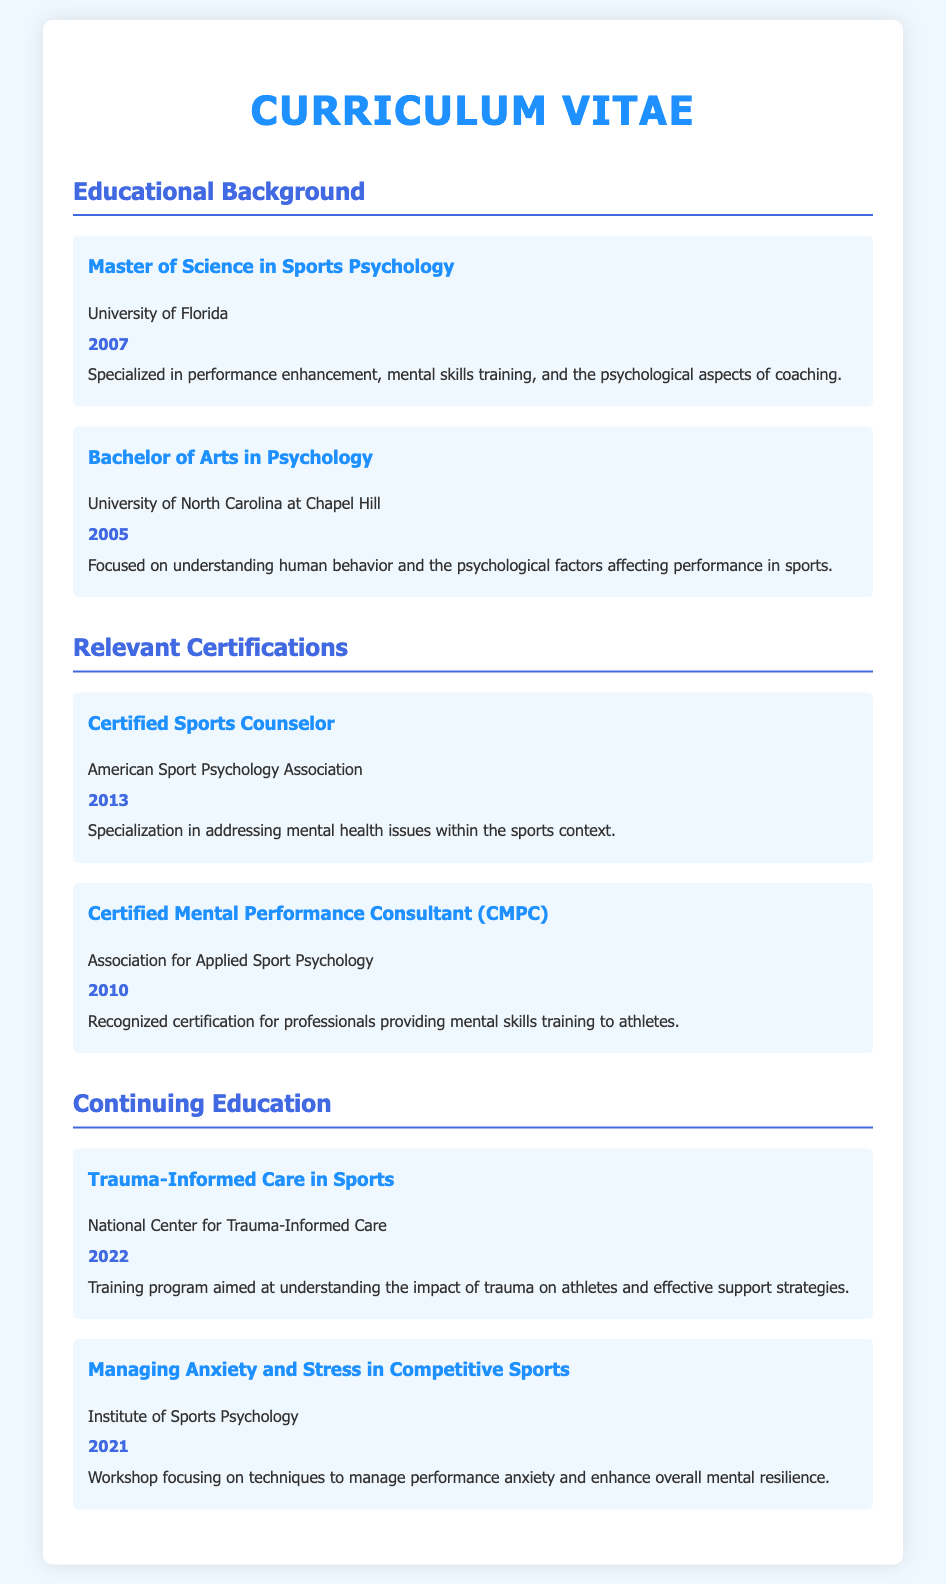What degree was obtained in 2007? The document states that a Master of Science in Sports Psychology was obtained in 2007.
Answer: Master of Science in Sports Psychology Which university awarded the Bachelor's degree? The document specifies that the Bachelor's degree was awarded by the University of North Carolina at Chapel Hill.
Answer: University of North Carolina at Chapel Hill What is the year of certification for Certified Sports Counselor? The document lists that the certification for Certified Sports Counselor was obtained in 2013.
Answer: 2013 Which certification is recognized for providing mental skills training? The document mentions that the Certified Mental Performance Consultant (CMPC) certification is recognized for this purpose.
Answer: Certified Mental Performance Consultant (CMPC) What is the focus of the Master of Science in Sports Psychology? The document states that it specializes in performance enhancement, mental skills training, and psychological aspects of coaching.
Answer: Performance enhancement, mental skills training, psychological aspects of coaching In which year did the training for Trauma-Informed Care in Sports occur? The document indicates that the training took place in 2022.
Answer: 2022 What organization offers the Certified Mental Performance Consultant certification? The document notes that the Association for Applied Sport Psychology offers this certification.
Answer: Association for Applied Sport Psychology What training program was completed in 2021? The document lists the workshop that was completed in 2021 as "Managing Anxiety and Stress in Competitive Sports."
Answer: Managing Anxiety and Stress in Competitive Sports What educational institution did the professional start their higher education? The document specifies that higher education began at the University of North Carolina at Chapel Hill.
Answer: University of North Carolina at Chapel Hill 